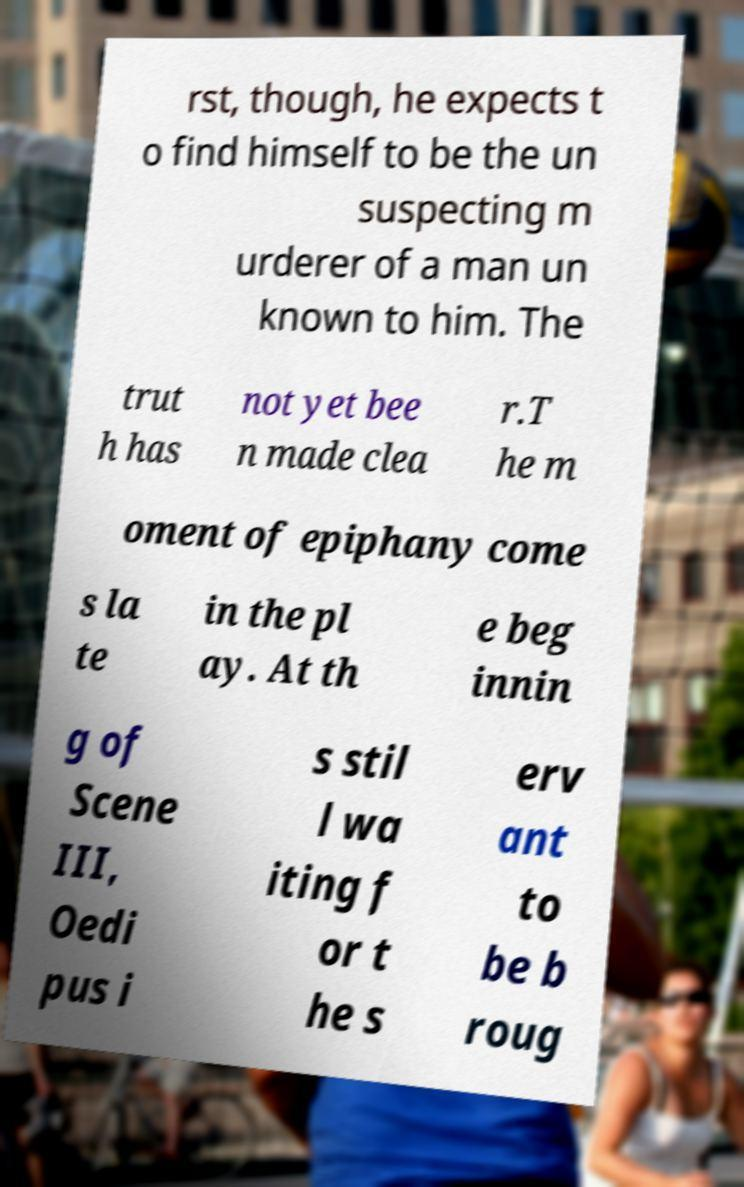What messages or text are displayed in this image? I need them in a readable, typed format. rst, though, he expects t o find himself to be the un suspecting m urderer of a man un known to him. The trut h has not yet bee n made clea r.T he m oment of epiphany come s la te in the pl ay. At th e beg innin g of Scene III, Oedi pus i s stil l wa iting f or t he s erv ant to be b roug 